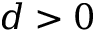<formula> <loc_0><loc_0><loc_500><loc_500>d > 0</formula> 